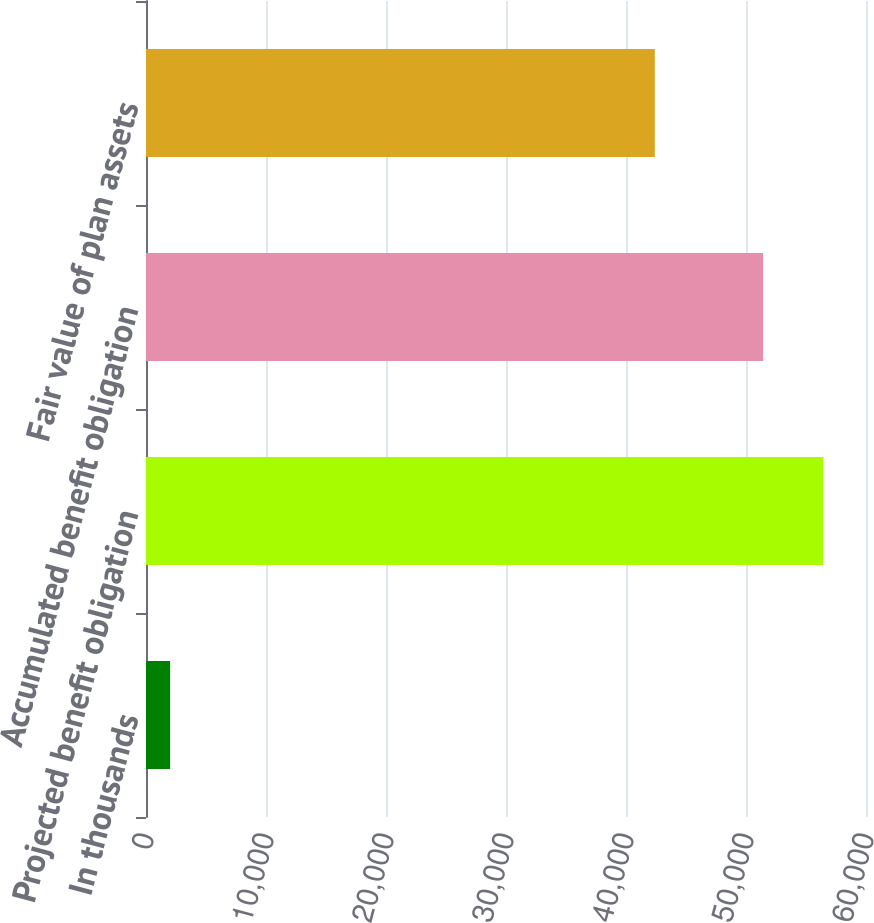Convert chart to OTSL. <chart><loc_0><loc_0><loc_500><loc_500><bar_chart><fcel>In thousands<fcel>Projected benefit obligation<fcel>Accumulated benefit obligation<fcel>Fair value of plan assets<nl><fcel>2012<fcel>56449.4<fcel>51428<fcel>42403<nl></chart> 